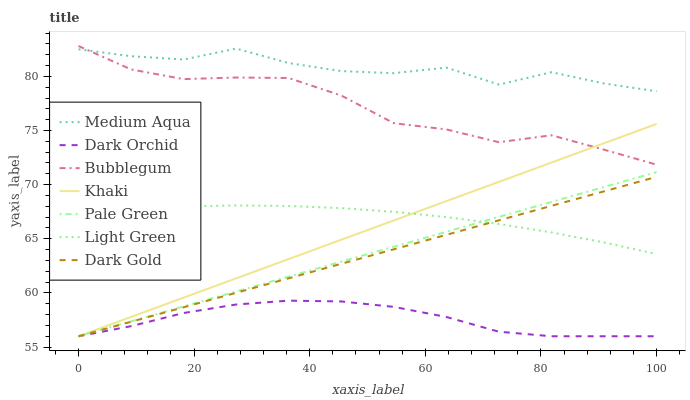Does Dark Orchid have the minimum area under the curve?
Answer yes or no. Yes. Does Medium Aqua have the maximum area under the curve?
Answer yes or no. Yes. Does Dark Gold have the minimum area under the curve?
Answer yes or no. No. Does Dark Gold have the maximum area under the curve?
Answer yes or no. No. Is Khaki the smoothest?
Answer yes or no. Yes. Is Medium Aqua the roughest?
Answer yes or no. Yes. Is Dark Gold the smoothest?
Answer yes or no. No. Is Dark Gold the roughest?
Answer yes or no. No. Does Khaki have the lowest value?
Answer yes or no. Yes. Does Bubblegum have the lowest value?
Answer yes or no. No. Does Bubblegum have the highest value?
Answer yes or no. Yes. Does Dark Gold have the highest value?
Answer yes or no. No. Is Dark Gold less than Medium Aqua?
Answer yes or no. Yes. Is Bubblegum greater than Dark Orchid?
Answer yes or no. Yes. Does Medium Aqua intersect Bubblegum?
Answer yes or no. Yes. Is Medium Aqua less than Bubblegum?
Answer yes or no. No. Is Medium Aqua greater than Bubblegum?
Answer yes or no. No. Does Dark Gold intersect Medium Aqua?
Answer yes or no. No. 